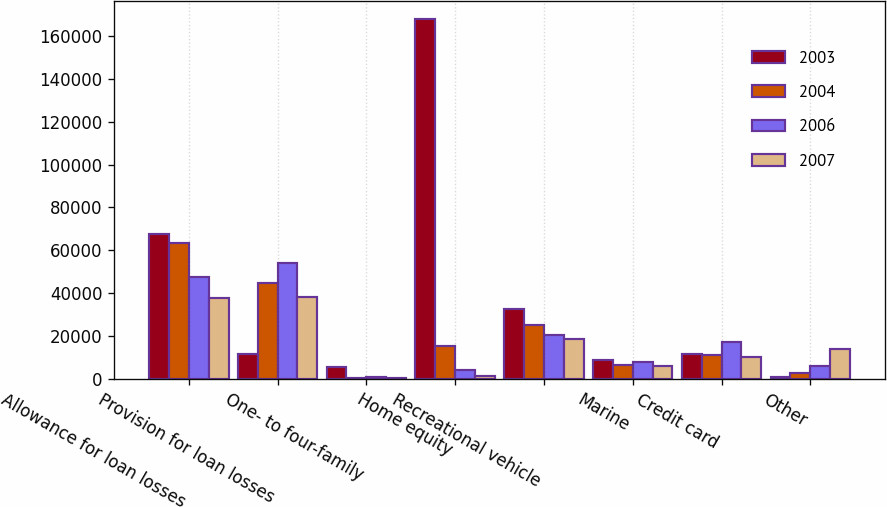Convert chart. <chart><loc_0><loc_0><loc_500><loc_500><stacked_bar_chart><ecel><fcel>Allowance for loan losses<fcel>Provision for loan losses<fcel>One- to four-family<fcel>Home equity<fcel>Recreational vehicle<fcel>Marine<fcel>Credit card<fcel>Other<nl><fcel>2003<fcel>67628<fcel>11608<fcel>5661<fcel>168163<fcel>32566<fcel>8766<fcel>11608<fcel>915<nl><fcel>2004<fcel>63286<fcel>44970<fcel>616<fcel>15372<fcel>25253<fcel>6463<fcel>11371<fcel>2768<nl><fcel>2006<fcel>47681<fcel>54016<fcel>936<fcel>3929<fcel>20592<fcel>8009<fcel>17286<fcel>6095<nl><fcel>2007<fcel>37847<fcel>38121<fcel>186<fcel>1464<fcel>18419<fcel>6003<fcel>10313<fcel>13956<nl></chart> 